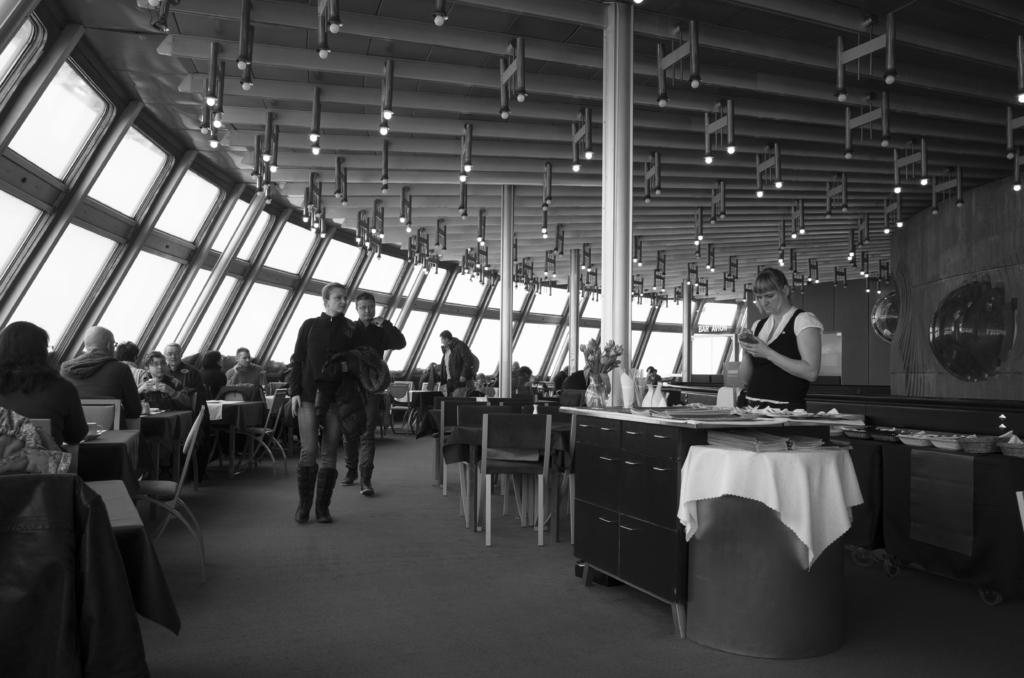What is the woman on the right side of the image wearing? The woman on the right side of the image is wearing a black and white dress. What can be seen at the top of the image? There are lights at the top of the image. What are the two people in the middle of the image doing? A woman and a man are walking in the middle of the image. What type of walls are present in the image? There are glass walls in the image. What type of board is visible in the image? There is no board present in the image. What is the title of the pot in the image? There is no pot or title present in the image. 